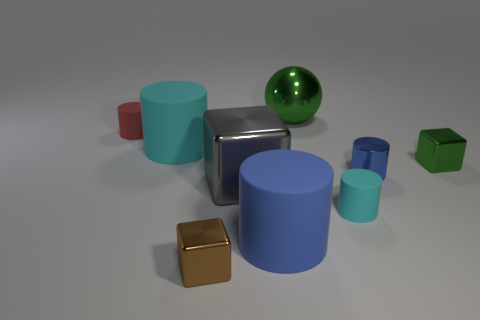There is a tiny block in front of the blue thing behind the cyan rubber cylinder that is in front of the gray metal block; what is it made of?
Offer a very short reply. Metal. What is the color of the big object behind the red matte thing?
Your response must be concise. Green. Are there any big cyan things that have the same shape as the blue matte object?
Provide a succinct answer. Yes. What is the green block made of?
Offer a very short reply. Metal. There is a shiny block that is both behind the big blue matte cylinder and left of the tiny green shiny block; what size is it?
Your answer should be very brief. Large. What material is the small object that is the same color as the shiny sphere?
Your response must be concise. Metal. What number of blue blocks are there?
Offer a terse response. 0. Are there fewer small red matte objects than big matte cubes?
Provide a succinct answer. No. There is a red cylinder that is the same size as the green cube; what is its material?
Offer a terse response. Rubber. What number of things are either gray shiny objects or blue metal things?
Your answer should be compact. 2. 